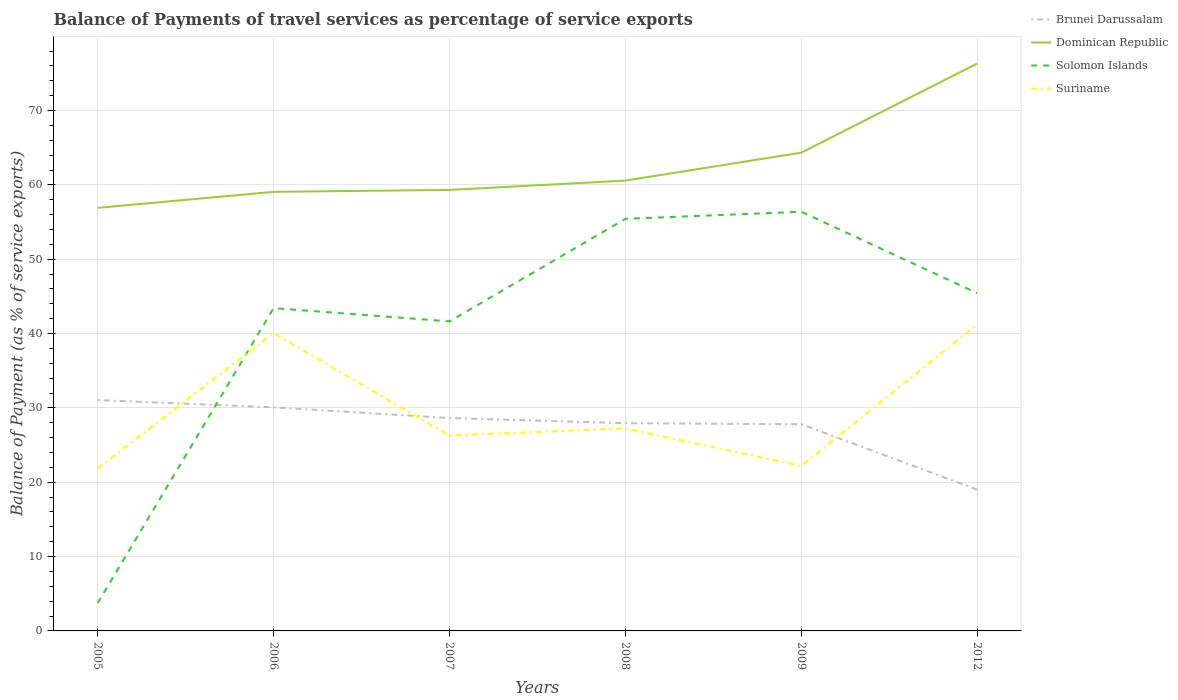How many different coloured lines are there?
Offer a terse response. 4. Is the number of lines equal to the number of legend labels?
Keep it short and to the point. Yes. Across all years, what is the maximum balance of payments of travel services in Suriname?
Offer a very short reply. 21.85. What is the total balance of payments of travel services in Dominican Republic in the graph?
Give a very brief answer. -1.51. What is the difference between the highest and the second highest balance of payments of travel services in Suriname?
Provide a short and direct response. 19.35. Is the balance of payments of travel services in Solomon Islands strictly greater than the balance of payments of travel services in Brunei Darussalam over the years?
Offer a terse response. No. How many lines are there?
Your response must be concise. 4. How many years are there in the graph?
Give a very brief answer. 6. What is the difference between two consecutive major ticks on the Y-axis?
Provide a succinct answer. 10. How many legend labels are there?
Provide a short and direct response. 4. What is the title of the graph?
Your answer should be compact. Balance of Payments of travel services as percentage of service exports. Does "United Arab Emirates" appear as one of the legend labels in the graph?
Offer a terse response. No. What is the label or title of the Y-axis?
Your answer should be very brief. Balance of Payment (as % of service exports). What is the Balance of Payment (as % of service exports) of Brunei Darussalam in 2005?
Offer a very short reply. 31.06. What is the Balance of Payment (as % of service exports) of Dominican Republic in 2005?
Provide a succinct answer. 56.92. What is the Balance of Payment (as % of service exports) of Solomon Islands in 2005?
Provide a succinct answer. 3.74. What is the Balance of Payment (as % of service exports) in Suriname in 2005?
Give a very brief answer. 21.85. What is the Balance of Payment (as % of service exports) in Brunei Darussalam in 2006?
Offer a very short reply. 30.08. What is the Balance of Payment (as % of service exports) of Dominican Republic in 2006?
Offer a terse response. 59.07. What is the Balance of Payment (as % of service exports) of Solomon Islands in 2006?
Make the answer very short. 43.42. What is the Balance of Payment (as % of service exports) in Suriname in 2006?
Your answer should be compact. 40.07. What is the Balance of Payment (as % of service exports) in Brunei Darussalam in 2007?
Offer a very short reply. 28.64. What is the Balance of Payment (as % of service exports) in Dominican Republic in 2007?
Offer a very short reply. 59.33. What is the Balance of Payment (as % of service exports) in Solomon Islands in 2007?
Provide a succinct answer. 41.65. What is the Balance of Payment (as % of service exports) of Suriname in 2007?
Offer a terse response. 26.28. What is the Balance of Payment (as % of service exports) of Brunei Darussalam in 2008?
Make the answer very short. 27.95. What is the Balance of Payment (as % of service exports) of Dominican Republic in 2008?
Keep it short and to the point. 60.58. What is the Balance of Payment (as % of service exports) in Solomon Islands in 2008?
Offer a terse response. 55.44. What is the Balance of Payment (as % of service exports) in Suriname in 2008?
Your response must be concise. 27.23. What is the Balance of Payment (as % of service exports) in Brunei Darussalam in 2009?
Offer a very short reply. 27.8. What is the Balance of Payment (as % of service exports) in Dominican Republic in 2009?
Provide a succinct answer. 64.34. What is the Balance of Payment (as % of service exports) of Solomon Islands in 2009?
Your answer should be compact. 56.39. What is the Balance of Payment (as % of service exports) of Suriname in 2009?
Give a very brief answer. 22.18. What is the Balance of Payment (as % of service exports) in Brunei Darussalam in 2012?
Your answer should be compact. 19.01. What is the Balance of Payment (as % of service exports) of Dominican Republic in 2012?
Keep it short and to the point. 76.33. What is the Balance of Payment (as % of service exports) in Solomon Islands in 2012?
Make the answer very short. 45.44. What is the Balance of Payment (as % of service exports) in Suriname in 2012?
Provide a short and direct response. 41.21. Across all years, what is the maximum Balance of Payment (as % of service exports) in Brunei Darussalam?
Make the answer very short. 31.06. Across all years, what is the maximum Balance of Payment (as % of service exports) of Dominican Republic?
Provide a short and direct response. 76.33. Across all years, what is the maximum Balance of Payment (as % of service exports) in Solomon Islands?
Provide a succinct answer. 56.39. Across all years, what is the maximum Balance of Payment (as % of service exports) in Suriname?
Make the answer very short. 41.21. Across all years, what is the minimum Balance of Payment (as % of service exports) of Brunei Darussalam?
Make the answer very short. 19.01. Across all years, what is the minimum Balance of Payment (as % of service exports) in Dominican Republic?
Your answer should be very brief. 56.92. Across all years, what is the minimum Balance of Payment (as % of service exports) in Solomon Islands?
Offer a terse response. 3.74. Across all years, what is the minimum Balance of Payment (as % of service exports) in Suriname?
Ensure brevity in your answer.  21.85. What is the total Balance of Payment (as % of service exports) in Brunei Darussalam in the graph?
Your answer should be compact. 164.53. What is the total Balance of Payment (as % of service exports) of Dominican Republic in the graph?
Offer a very short reply. 376.57. What is the total Balance of Payment (as % of service exports) in Solomon Islands in the graph?
Your answer should be very brief. 246.08. What is the total Balance of Payment (as % of service exports) in Suriname in the graph?
Your response must be concise. 178.82. What is the difference between the Balance of Payment (as % of service exports) in Brunei Darussalam in 2005 and that in 2006?
Offer a terse response. 0.98. What is the difference between the Balance of Payment (as % of service exports) in Dominican Republic in 2005 and that in 2006?
Your answer should be compact. -2.15. What is the difference between the Balance of Payment (as % of service exports) in Solomon Islands in 2005 and that in 2006?
Provide a short and direct response. -39.69. What is the difference between the Balance of Payment (as % of service exports) in Suriname in 2005 and that in 2006?
Your response must be concise. -18.22. What is the difference between the Balance of Payment (as % of service exports) of Brunei Darussalam in 2005 and that in 2007?
Make the answer very short. 2.42. What is the difference between the Balance of Payment (as % of service exports) of Dominican Republic in 2005 and that in 2007?
Give a very brief answer. -2.41. What is the difference between the Balance of Payment (as % of service exports) in Solomon Islands in 2005 and that in 2007?
Your answer should be compact. -37.91. What is the difference between the Balance of Payment (as % of service exports) of Suriname in 2005 and that in 2007?
Keep it short and to the point. -4.43. What is the difference between the Balance of Payment (as % of service exports) in Brunei Darussalam in 2005 and that in 2008?
Make the answer very short. 3.11. What is the difference between the Balance of Payment (as % of service exports) of Dominican Republic in 2005 and that in 2008?
Offer a terse response. -3.67. What is the difference between the Balance of Payment (as % of service exports) in Solomon Islands in 2005 and that in 2008?
Provide a succinct answer. -51.7. What is the difference between the Balance of Payment (as % of service exports) in Suriname in 2005 and that in 2008?
Ensure brevity in your answer.  -5.38. What is the difference between the Balance of Payment (as % of service exports) in Brunei Darussalam in 2005 and that in 2009?
Provide a short and direct response. 3.25. What is the difference between the Balance of Payment (as % of service exports) of Dominican Republic in 2005 and that in 2009?
Your answer should be compact. -7.42. What is the difference between the Balance of Payment (as % of service exports) in Solomon Islands in 2005 and that in 2009?
Ensure brevity in your answer.  -52.65. What is the difference between the Balance of Payment (as % of service exports) of Suriname in 2005 and that in 2009?
Offer a very short reply. -0.33. What is the difference between the Balance of Payment (as % of service exports) of Brunei Darussalam in 2005 and that in 2012?
Give a very brief answer. 12.05. What is the difference between the Balance of Payment (as % of service exports) in Dominican Republic in 2005 and that in 2012?
Provide a succinct answer. -19.41. What is the difference between the Balance of Payment (as % of service exports) of Solomon Islands in 2005 and that in 2012?
Offer a very short reply. -41.7. What is the difference between the Balance of Payment (as % of service exports) in Suriname in 2005 and that in 2012?
Give a very brief answer. -19.35. What is the difference between the Balance of Payment (as % of service exports) of Brunei Darussalam in 2006 and that in 2007?
Your answer should be compact. 1.44. What is the difference between the Balance of Payment (as % of service exports) in Dominican Republic in 2006 and that in 2007?
Offer a very short reply. -0.26. What is the difference between the Balance of Payment (as % of service exports) in Solomon Islands in 2006 and that in 2007?
Your answer should be compact. 1.78. What is the difference between the Balance of Payment (as % of service exports) of Suriname in 2006 and that in 2007?
Your answer should be very brief. 13.79. What is the difference between the Balance of Payment (as % of service exports) of Brunei Darussalam in 2006 and that in 2008?
Give a very brief answer. 2.13. What is the difference between the Balance of Payment (as % of service exports) of Dominican Republic in 2006 and that in 2008?
Keep it short and to the point. -1.51. What is the difference between the Balance of Payment (as % of service exports) in Solomon Islands in 2006 and that in 2008?
Your response must be concise. -12.01. What is the difference between the Balance of Payment (as % of service exports) in Suriname in 2006 and that in 2008?
Provide a short and direct response. 12.83. What is the difference between the Balance of Payment (as % of service exports) of Brunei Darussalam in 2006 and that in 2009?
Ensure brevity in your answer.  2.28. What is the difference between the Balance of Payment (as % of service exports) of Dominican Republic in 2006 and that in 2009?
Provide a succinct answer. -5.27. What is the difference between the Balance of Payment (as % of service exports) of Solomon Islands in 2006 and that in 2009?
Your answer should be very brief. -12.96. What is the difference between the Balance of Payment (as % of service exports) of Suriname in 2006 and that in 2009?
Give a very brief answer. 17.88. What is the difference between the Balance of Payment (as % of service exports) in Brunei Darussalam in 2006 and that in 2012?
Offer a terse response. 11.07. What is the difference between the Balance of Payment (as % of service exports) in Dominican Republic in 2006 and that in 2012?
Offer a terse response. -17.26. What is the difference between the Balance of Payment (as % of service exports) of Solomon Islands in 2006 and that in 2012?
Your answer should be compact. -2.02. What is the difference between the Balance of Payment (as % of service exports) of Suriname in 2006 and that in 2012?
Offer a very short reply. -1.14. What is the difference between the Balance of Payment (as % of service exports) of Brunei Darussalam in 2007 and that in 2008?
Your answer should be very brief. 0.69. What is the difference between the Balance of Payment (as % of service exports) in Dominican Republic in 2007 and that in 2008?
Ensure brevity in your answer.  -1.25. What is the difference between the Balance of Payment (as % of service exports) of Solomon Islands in 2007 and that in 2008?
Make the answer very short. -13.79. What is the difference between the Balance of Payment (as % of service exports) of Suriname in 2007 and that in 2008?
Give a very brief answer. -0.95. What is the difference between the Balance of Payment (as % of service exports) in Brunei Darussalam in 2007 and that in 2009?
Your answer should be very brief. 0.84. What is the difference between the Balance of Payment (as % of service exports) in Dominican Republic in 2007 and that in 2009?
Make the answer very short. -5.01. What is the difference between the Balance of Payment (as % of service exports) of Solomon Islands in 2007 and that in 2009?
Make the answer very short. -14.74. What is the difference between the Balance of Payment (as % of service exports) in Suriname in 2007 and that in 2009?
Your response must be concise. 4.1. What is the difference between the Balance of Payment (as % of service exports) of Brunei Darussalam in 2007 and that in 2012?
Provide a succinct answer. 9.63. What is the difference between the Balance of Payment (as % of service exports) of Dominican Republic in 2007 and that in 2012?
Keep it short and to the point. -17. What is the difference between the Balance of Payment (as % of service exports) in Solomon Islands in 2007 and that in 2012?
Make the answer very short. -3.8. What is the difference between the Balance of Payment (as % of service exports) of Suriname in 2007 and that in 2012?
Your answer should be very brief. -14.92. What is the difference between the Balance of Payment (as % of service exports) of Brunei Darussalam in 2008 and that in 2009?
Make the answer very short. 0.14. What is the difference between the Balance of Payment (as % of service exports) of Dominican Republic in 2008 and that in 2009?
Your answer should be compact. -3.76. What is the difference between the Balance of Payment (as % of service exports) in Solomon Islands in 2008 and that in 2009?
Ensure brevity in your answer.  -0.95. What is the difference between the Balance of Payment (as % of service exports) in Suriname in 2008 and that in 2009?
Give a very brief answer. 5.05. What is the difference between the Balance of Payment (as % of service exports) in Brunei Darussalam in 2008 and that in 2012?
Keep it short and to the point. 8.94. What is the difference between the Balance of Payment (as % of service exports) in Dominican Republic in 2008 and that in 2012?
Your answer should be compact. -15.75. What is the difference between the Balance of Payment (as % of service exports) of Solomon Islands in 2008 and that in 2012?
Your answer should be compact. 9.99. What is the difference between the Balance of Payment (as % of service exports) of Suriname in 2008 and that in 2012?
Give a very brief answer. -13.97. What is the difference between the Balance of Payment (as % of service exports) of Brunei Darussalam in 2009 and that in 2012?
Ensure brevity in your answer.  8.8. What is the difference between the Balance of Payment (as % of service exports) of Dominican Republic in 2009 and that in 2012?
Keep it short and to the point. -11.99. What is the difference between the Balance of Payment (as % of service exports) of Solomon Islands in 2009 and that in 2012?
Keep it short and to the point. 10.95. What is the difference between the Balance of Payment (as % of service exports) of Suriname in 2009 and that in 2012?
Offer a very short reply. -19.02. What is the difference between the Balance of Payment (as % of service exports) of Brunei Darussalam in 2005 and the Balance of Payment (as % of service exports) of Dominican Republic in 2006?
Your answer should be very brief. -28.01. What is the difference between the Balance of Payment (as % of service exports) of Brunei Darussalam in 2005 and the Balance of Payment (as % of service exports) of Solomon Islands in 2006?
Ensure brevity in your answer.  -12.37. What is the difference between the Balance of Payment (as % of service exports) of Brunei Darussalam in 2005 and the Balance of Payment (as % of service exports) of Suriname in 2006?
Your answer should be very brief. -9.01. What is the difference between the Balance of Payment (as % of service exports) in Dominican Republic in 2005 and the Balance of Payment (as % of service exports) in Solomon Islands in 2006?
Give a very brief answer. 13.49. What is the difference between the Balance of Payment (as % of service exports) of Dominican Republic in 2005 and the Balance of Payment (as % of service exports) of Suriname in 2006?
Provide a short and direct response. 16.85. What is the difference between the Balance of Payment (as % of service exports) in Solomon Islands in 2005 and the Balance of Payment (as % of service exports) in Suriname in 2006?
Provide a succinct answer. -36.33. What is the difference between the Balance of Payment (as % of service exports) of Brunei Darussalam in 2005 and the Balance of Payment (as % of service exports) of Dominican Republic in 2007?
Your response must be concise. -28.27. What is the difference between the Balance of Payment (as % of service exports) in Brunei Darussalam in 2005 and the Balance of Payment (as % of service exports) in Solomon Islands in 2007?
Offer a very short reply. -10.59. What is the difference between the Balance of Payment (as % of service exports) in Brunei Darussalam in 2005 and the Balance of Payment (as % of service exports) in Suriname in 2007?
Your answer should be very brief. 4.77. What is the difference between the Balance of Payment (as % of service exports) in Dominican Republic in 2005 and the Balance of Payment (as % of service exports) in Solomon Islands in 2007?
Provide a short and direct response. 15.27. What is the difference between the Balance of Payment (as % of service exports) in Dominican Republic in 2005 and the Balance of Payment (as % of service exports) in Suriname in 2007?
Provide a succinct answer. 30.63. What is the difference between the Balance of Payment (as % of service exports) of Solomon Islands in 2005 and the Balance of Payment (as % of service exports) of Suriname in 2007?
Offer a terse response. -22.54. What is the difference between the Balance of Payment (as % of service exports) in Brunei Darussalam in 2005 and the Balance of Payment (as % of service exports) in Dominican Republic in 2008?
Your response must be concise. -29.53. What is the difference between the Balance of Payment (as % of service exports) of Brunei Darussalam in 2005 and the Balance of Payment (as % of service exports) of Solomon Islands in 2008?
Your answer should be very brief. -24.38. What is the difference between the Balance of Payment (as % of service exports) in Brunei Darussalam in 2005 and the Balance of Payment (as % of service exports) in Suriname in 2008?
Provide a succinct answer. 3.82. What is the difference between the Balance of Payment (as % of service exports) of Dominican Republic in 2005 and the Balance of Payment (as % of service exports) of Solomon Islands in 2008?
Offer a very short reply. 1.48. What is the difference between the Balance of Payment (as % of service exports) of Dominican Republic in 2005 and the Balance of Payment (as % of service exports) of Suriname in 2008?
Offer a very short reply. 29.68. What is the difference between the Balance of Payment (as % of service exports) of Solomon Islands in 2005 and the Balance of Payment (as % of service exports) of Suriname in 2008?
Offer a terse response. -23.5. What is the difference between the Balance of Payment (as % of service exports) of Brunei Darussalam in 2005 and the Balance of Payment (as % of service exports) of Dominican Republic in 2009?
Keep it short and to the point. -33.28. What is the difference between the Balance of Payment (as % of service exports) in Brunei Darussalam in 2005 and the Balance of Payment (as % of service exports) in Solomon Islands in 2009?
Offer a very short reply. -25.33. What is the difference between the Balance of Payment (as % of service exports) in Brunei Darussalam in 2005 and the Balance of Payment (as % of service exports) in Suriname in 2009?
Your answer should be compact. 8.87. What is the difference between the Balance of Payment (as % of service exports) of Dominican Republic in 2005 and the Balance of Payment (as % of service exports) of Solomon Islands in 2009?
Offer a terse response. 0.53. What is the difference between the Balance of Payment (as % of service exports) of Dominican Republic in 2005 and the Balance of Payment (as % of service exports) of Suriname in 2009?
Keep it short and to the point. 34.73. What is the difference between the Balance of Payment (as % of service exports) in Solomon Islands in 2005 and the Balance of Payment (as % of service exports) in Suriname in 2009?
Your answer should be compact. -18.45. What is the difference between the Balance of Payment (as % of service exports) in Brunei Darussalam in 2005 and the Balance of Payment (as % of service exports) in Dominican Republic in 2012?
Make the answer very short. -45.27. What is the difference between the Balance of Payment (as % of service exports) of Brunei Darussalam in 2005 and the Balance of Payment (as % of service exports) of Solomon Islands in 2012?
Offer a terse response. -14.39. What is the difference between the Balance of Payment (as % of service exports) in Brunei Darussalam in 2005 and the Balance of Payment (as % of service exports) in Suriname in 2012?
Make the answer very short. -10.15. What is the difference between the Balance of Payment (as % of service exports) of Dominican Republic in 2005 and the Balance of Payment (as % of service exports) of Solomon Islands in 2012?
Make the answer very short. 11.47. What is the difference between the Balance of Payment (as % of service exports) of Dominican Republic in 2005 and the Balance of Payment (as % of service exports) of Suriname in 2012?
Your answer should be very brief. 15.71. What is the difference between the Balance of Payment (as % of service exports) in Solomon Islands in 2005 and the Balance of Payment (as % of service exports) in Suriname in 2012?
Keep it short and to the point. -37.47. What is the difference between the Balance of Payment (as % of service exports) of Brunei Darussalam in 2006 and the Balance of Payment (as % of service exports) of Dominican Republic in 2007?
Make the answer very short. -29.25. What is the difference between the Balance of Payment (as % of service exports) in Brunei Darussalam in 2006 and the Balance of Payment (as % of service exports) in Solomon Islands in 2007?
Offer a terse response. -11.57. What is the difference between the Balance of Payment (as % of service exports) of Brunei Darussalam in 2006 and the Balance of Payment (as % of service exports) of Suriname in 2007?
Give a very brief answer. 3.8. What is the difference between the Balance of Payment (as % of service exports) in Dominican Republic in 2006 and the Balance of Payment (as % of service exports) in Solomon Islands in 2007?
Make the answer very short. 17.42. What is the difference between the Balance of Payment (as % of service exports) in Dominican Republic in 2006 and the Balance of Payment (as % of service exports) in Suriname in 2007?
Offer a very short reply. 32.79. What is the difference between the Balance of Payment (as % of service exports) of Solomon Islands in 2006 and the Balance of Payment (as % of service exports) of Suriname in 2007?
Ensure brevity in your answer.  17.14. What is the difference between the Balance of Payment (as % of service exports) in Brunei Darussalam in 2006 and the Balance of Payment (as % of service exports) in Dominican Republic in 2008?
Offer a terse response. -30.5. What is the difference between the Balance of Payment (as % of service exports) in Brunei Darussalam in 2006 and the Balance of Payment (as % of service exports) in Solomon Islands in 2008?
Your answer should be compact. -25.36. What is the difference between the Balance of Payment (as % of service exports) in Brunei Darussalam in 2006 and the Balance of Payment (as % of service exports) in Suriname in 2008?
Your response must be concise. 2.85. What is the difference between the Balance of Payment (as % of service exports) of Dominican Republic in 2006 and the Balance of Payment (as % of service exports) of Solomon Islands in 2008?
Make the answer very short. 3.63. What is the difference between the Balance of Payment (as % of service exports) in Dominican Republic in 2006 and the Balance of Payment (as % of service exports) in Suriname in 2008?
Your response must be concise. 31.83. What is the difference between the Balance of Payment (as % of service exports) in Solomon Islands in 2006 and the Balance of Payment (as % of service exports) in Suriname in 2008?
Offer a terse response. 16.19. What is the difference between the Balance of Payment (as % of service exports) of Brunei Darussalam in 2006 and the Balance of Payment (as % of service exports) of Dominican Republic in 2009?
Keep it short and to the point. -34.26. What is the difference between the Balance of Payment (as % of service exports) of Brunei Darussalam in 2006 and the Balance of Payment (as % of service exports) of Solomon Islands in 2009?
Your answer should be compact. -26.31. What is the difference between the Balance of Payment (as % of service exports) of Brunei Darussalam in 2006 and the Balance of Payment (as % of service exports) of Suriname in 2009?
Make the answer very short. 7.9. What is the difference between the Balance of Payment (as % of service exports) in Dominican Republic in 2006 and the Balance of Payment (as % of service exports) in Solomon Islands in 2009?
Give a very brief answer. 2.68. What is the difference between the Balance of Payment (as % of service exports) of Dominican Republic in 2006 and the Balance of Payment (as % of service exports) of Suriname in 2009?
Offer a very short reply. 36.89. What is the difference between the Balance of Payment (as % of service exports) of Solomon Islands in 2006 and the Balance of Payment (as % of service exports) of Suriname in 2009?
Make the answer very short. 21.24. What is the difference between the Balance of Payment (as % of service exports) in Brunei Darussalam in 2006 and the Balance of Payment (as % of service exports) in Dominican Republic in 2012?
Your response must be concise. -46.25. What is the difference between the Balance of Payment (as % of service exports) in Brunei Darussalam in 2006 and the Balance of Payment (as % of service exports) in Solomon Islands in 2012?
Offer a very short reply. -15.36. What is the difference between the Balance of Payment (as % of service exports) in Brunei Darussalam in 2006 and the Balance of Payment (as % of service exports) in Suriname in 2012?
Offer a terse response. -11.12. What is the difference between the Balance of Payment (as % of service exports) in Dominican Republic in 2006 and the Balance of Payment (as % of service exports) in Solomon Islands in 2012?
Provide a short and direct response. 13.63. What is the difference between the Balance of Payment (as % of service exports) of Dominican Republic in 2006 and the Balance of Payment (as % of service exports) of Suriname in 2012?
Keep it short and to the point. 17.86. What is the difference between the Balance of Payment (as % of service exports) in Solomon Islands in 2006 and the Balance of Payment (as % of service exports) in Suriname in 2012?
Your response must be concise. 2.22. What is the difference between the Balance of Payment (as % of service exports) of Brunei Darussalam in 2007 and the Balance of Payment (as % of service exports) of Dominican Republic in 2008?
Offer a terse response. -31.94. What is the difference between the Balance of Payment (as % of service exports) in Brunei Darussalam in 2007 and the Balance of Payment (as % of service exports) in Solomon Islands in 2008?
Make the answer very short. -26.8. What is the difference between the Balance of Payment (as % of service exports) in Brunei Darussalam in 2007 and the Balance of Payment (as % of service exports) in Suriname in 2008?
Ensure brevity in your answer.  1.41. What is the difference between the Balance of Payment (as % of service exports) of Dominican Republic in 2007 and the Balance of Payment (as % of service exports) of Solomon Islands in 2008?
Ensure brevity in your answer.  3.89. What is the difference between the Balance of Payment (as % of service exports) of Dominican Republic in 2007 and the Balance of Payment (as % of service exports) of Suriname in 2008?
Make the answer very short. 32.09. What is the difference between the Balance of Payment (as % of service exports) of Solomon Islands in 2007 and the Balance of Payment (as % of service exports) of Suriname in 2008?
Keep it short and to the point. 14.41. What is the difference between the Balance of Payment (as % of service exports) of Brunei Darussalam in 2007 and the Balance of Payment (as % of service exports) of Dominican Republic in 2009?
Ensure brevity in your answer.  -35.7. What is the difference between the Balance of Payment (as % of service exports) in Brunei Darussalam in 2007 and the Balance of Payment (as % of service exports) in Solomon Islands in 2009?
Offer a terse response. -27.75. What is the difference between the Balance of Payment (as % of service exports) in Brunei Darussalam in 2007 and the Balance of Payment (as % of service exports) in Suriname in 2009?
Provide a short and direct response. 6.46. What is the difference between the Balance of Payment (as % of service exports) of Dominican Republic in 2007 and the Balance of Payment (as % of service exports) of Solomon Islands in 2009?
Offer a terse response. 2.94. What is the difference between the Balance of Payment (as % of service exports) in Dominican Republic in 2007 and the Balance of Payment (as % of service exports) in Suriname in 2009?
Offer a terse response. 37.15. What is the difference between the Balance of Payment (as % of service exports) in Solomon Islands in 2007 and the Balance of Payment (as % of service exports) in Suriname in 2009?
Keep it short and to the point. 19.46. What is the difference between the Balance of Payment (as % of service exports) of Brunei Darussalam in 2007 and the Balance of Payment (as % of service exports) of Dominican Republic in 2012?
Your answer should be compact. -47.69. What is the difference between the Balance of Payment (as % of service exports) in Brunei Darussalam in 2007 and the Balance of Payment (as % of service exports) in Solomon Islands in 2012?
Give a very brief answer. -16.8. What is the difference between the Balance of Payment (as % of service exports) in Brunei Darussalam in 2007 and the Balance of Payment (as % of service exports) in Suriname in 2012?
Make the answer very short. -12.56. What is the difference between the Balance of Payment (as % of service exports) in Dominican Republic in 2007 and the Balance of Payment (as % of service exports) in Solomon Islands in 2012?
Give a very brief answer. 13.89. What is the difference between the Balance of Payment (as % of service exports) in Dominican Republic in 2007 and the Balance of Payment (as % of service exports) in Suriname in 2012?
Give a very brief answer. 18.12. What is the difference between the Balance of Payment (as % of service exports) of Solomon Islands in 2007 and the Balance of Payment (as % of service exports) of Suriname in 2012?
Give a very brief answer. 0.44. What is the difference between the Balance of Payment (as % of service exports) in Brunei Darussalam in 2008 and the Balance of Payment (as % of service exports) in Dominican Republic in 2009?
Offer a very short reply. -36.39. What is the difference between the Balance of Payment (as % of service exports) of Brunei Darussalam in 2008 and the Balance of Payment (as % of service exports) of Solomon Islands in 2009?
Your answer should be very brief. -28.44. What is the difference between the Balance of Payment (as % of service exports) in Brunei Darussalam in 2008 and the Balance of Payment (as % of service exports) in Suriname in 2009?
Offer a terse response. 5.76. What is the difference between the Balance of Payment (as % of service exports) in Dominican Republic in 2008 and the Balance of Payment (as % of service exports) in Solomon Islands in 2009?
Provide a succinct answer. 4.19. What is the difference between the Balance of Payment (as % of service exports) in Dominican Republic in 2008 and the Balance of Payment (as % of service exports) in Suriname in 2009?
Your answer should be very brief. 38.4. What is the difference between the Balance of Payment (as % of service exports) in Solomon Islands in 2008 and the Balance of Payment (as % of service exports) in Suriname in 2009?
Make the answer very short. 33.25. What is the difference between the Balance of Payment (as % of service exports) in Brunei Darussalam in 2008 and the Balance of Payment (as % of service exports) in Dominican Republic in 2012?
Keep it short and to the point. -48.38. What is the difference between the Balance of Payment (as % of service exports) of Brunei Darussalam in 2008 and the Balance of Payment (as % of service exports) of Solomon Islands in 2012?
Your answer should be very brief. -17.5. What is the difference between the Balance of Payment (as % of service exports) of Brunei Darussalam in 2008 and the Balance of Payment (as % of service exports) of Suriname in 2012?
Your answer should be compact. -13.26. What is the difference between the Balance of Payment (as % of service exports) of Dominican Republic in 2008 and the Balance of Payment (as % of service exports) of Solomon Islands in 2012?
Offer a terse response. 15.14. What is the difference between the Balance of Payment (as % of service exports) of Dominican Republic in 2008 and the Balance of Payment (as % of service exports) of Suriname in 2012?
Ensure brevity in your answer.  19.38. What is the difference between the Balance of Payment (as % of service exports) in Solomon Islands in 2008 and the Balance of Payment (as % of service exports) in Suriname in 2012?
Ensure brevity in your answer.  14.23. What is the difference between the Balance of Payment (as % of service exports) of Brunei Darussalam in 2009 and the Balance of Payment (as % of service exports) of Dominican Republic in 2012?
Ensure brevity in your answer.  -48.53. What is the difference between the Balance of Payment (as % of service exports) of Brunei Darussalam in 2009 and the Balance of Payment (as % of service exports) of Solomon Islands in 2012?
Offer a very short reply. -17.64. What is the difference between the Balance of Payment (as % of service exports) of Brunei Darussalam in 2009 and the Balance of Payment (as % of service exports) of Suriname in 2012?
Your response must be concise. -13.4. What is the difference between the Balance of Payment (as % of service exports) of Dominican Republic in 2009 and the Balance of Payment (as % of service exports) of Solomon Islands in 2012?
Make the answer very short. 18.9. What is the difference between the Balance of Payment (as % of service exports) in Dominican Republic in 2009 and the Balance of Payment (as % of service exports) in Suriname in 2012?
Make the answer very short. 23.14. What is the difference between the Balance of Payment (as % of service exports) of Solomon Islands in 2009 and the Balance of Payment (as % of service exports) of Suriname in 2012?
Offer a terse response. 15.18. What is the average Balance of Payment (as % of service exports) in Brunei Darussalam per year?
Ensure brevity in your answer.  27.42. What is the average Balance of Payment (as % of service exports) of Dominican Republic per year?
Offer a very short reply. 62.76. What is the average Balance of Payment (as % of service exports) of Solomon Islands per year?
Make the answer very short. 41.01. What is the average Balance of Payment (as % of service exports) of Suriname per year?
Make the answer very short. 29.8. In the year 2005, what is the difference between the Balance of Payment (as % of service exports) in Brunei Darussalam and Balance of Payment (as % of service exports) in Dominican Republic?
Your answer should be very brief. -25.86. In the year 2005, what is the difference between the Balance of Payment (as % of service exports) in Brunei Darussalam and Balance of Payment (as % of service exports) in Solomon Islands?
Make the answer very short. 27.32. In the year 2005, what is the difference between the Balance of Payment (as % of service exports) in Brunei Darussalam and Balance of Payment (as % of service exports) in Suriname?
Provide a succinct answer. 9.2. In the year 2005, what is the difference between the Balance of Payment (as % of service exports) of Dominican Republic and Balance of Payment (as % of service exports) of Solomon Islands?
Give a very brief answer. 53.18. In the year 2005, what is the difference between the Balance of Payment (as % of service exports) in Dominican Republic and Balance of Payment (as % of service exports) in Suriname?
Ensure brevity in your answer.  35.06. In the year 2005, what is the difference between the Balance of Payment (as % of service exports) in Solomon Islands and Balance of Payment (as % of service exports) in Suriname?
Give a very brief answer. -18.11. In the year 2006, what is the difference between the Balance of Payment (as % of service exports) in Brunei Darussalam and Balance of Payment (as % of service exports) in Dominican Republic?
Keep it short and to the point. -28.99. In the year 2006, what is the difference between the Balance of Payment (as % of service exports) of Brunei Darussalam and Balance of Payment (as % of service exports) of Solomon Islands?
Provide a short and direct response. -13.34. In the year 2006, what is the difference between the Balance of Payment (as % of service exports) in Brunei Darussalam and Balance of Payment (as % of service exports) in Suriname?
Provide a short and direct response. -9.99. In the year 2006, what is the difference between the Balance of Payment (as % of service exports) in Dominican Republic and Balance of Payment (as % of service exports) in Solomon Islands?
Offer a very short reply. 15.64. In the year 2006, what is the difference between the Balance of Payment (as % of service exports) in Dominican Republic and Balance of Payment (as % of service exports) in Suriname?
Your response must be concise. 19. In the year 2006, what is the difference between the Balance of Payment (as % of service exports) of Solomon Islands and Balance of Payment (as % of service exports) of Suriname?
Offer a very short reply. 3.36. In the year 2007, what is the difference between the Balance of Payment (as % of service exports) in Brunei Darussalam and Balance of Payment (as % of service exports) in Dominican Republic?
Your response must be concise. -30.69. In the year 2007, what is the difference between the Balance of Payment (as % of service exports) of Brunei Darussalam and Balance of Payment (as % of service exports) of Solomon Islands?
Your answer should be very brief. -13.01. In the year 2007, what is the difference between the Balance of Payment (as % of service exports) in Brunei Darussalam and Balance of Payment (as % of service exports) in Suriname?
Provide a short and direct response. 2.36. In the year 2007, what is the difference between the Balance of Payment (as % of service exports) in Dominican Republic and Balance of Payment (as % of service exports) in Solomon Islands?
Give a very brief answer. 17.68. In the year 2007, what is the difference between the Balance of Payment (as % of service exports) in Dominican Republic and Balance of Payment (as % of service exports) in Suriname?
Offer a very short reply. 33.05. In the year 2007, what is the difference between the Balance of Payment (as % of service exports) of Solomon Islands and Balance of Payment (as % of service exports) of Suriname?
Provide a short and direct response. 15.36. In the year 2008, what is the difference between the Balance of Payment (as % of service exports) of Brunei Darussalam and Balance of Payment (as % of service exports) of Dominican Republic?
Keep it short and to the point. -32.64. In the year 2008, what is the difference between the Balance of Payment (as % of service exports) in Brunei Darussalam and Balance of Payment (as % of service exports) in Solomon Islands?
Ensure brevity in your answer.  -27.49. In the year 2008, what is the difference between the Balance of Payment (as % of service exports) of Brunei Darussalam and Balance of Payment (as % of service exports) of Suriname?
Provide a short and direct response. 0.71. In the year 2008, what is the difference between the Balance of Payment (as % of service exports) of Dominican Republic and Balance of Payment (as % of service exports) of Solomon Islands?
Your response must be concise. 5.15. In the year 2008, what is the difference between the Balance of Payment (as % of service exports) in Dominican Republic and Balance of Payment (as % of service exports) in Suriname?
Give a very brief answer. 33.35. In the year 2008, what is the difference between the Balance of Payment (as % of service exports) of Solomon Islands and Balance of Payment (as % of service exports) of Suriname?
Provide a succinct answer. 28.2. In the year 2009, what is the difference between the Balance of Payment (as % of service exports) in Brunei Darussalam and Balance of Payment (as % of service exports) in Dominican Republic?
Provide a succinct answer. -36.54. In the year 2009, what is the difference between the Balance of Payment (as % of service exports) of Brunei Darussalam and Balance of Payment (as % of service exports) of Solomon Islands?
Make the answer very short. -28.59. In the year 2009, what is the difference between the Balance of Payment (as % of service exports) in Brunei Darussalam and Balance of Payment (as % of service exports) in Suriname?
Give a very brief answer. 5.62. In the year 2009, what is the difference between the Balance of Payment (as % of service exports) of Dominican Republic and Balance of Payment (as % of service exports) of Solomon Islands?
Your answer should be very brief. 7.95. In the year 2009, what is the difference between the Balance of Payment (as % of service exports) of Dominican Republic and Balance of Payment (as % of service exports) of Suriname?
Provide a short and direct response. 42.16. In the year 2009, what is the difference between the Balance of Payment (as % of service exports) of Solomon Islands and Balance of Payment (as % of service exports) of Suriname?
Provide a succinct answer. 34.21. In the year 2012, what is the difference between the Balance of Payment (as % of service exports) in Brunei Darussalam and Balance of Payment (as % of service exports) in Dominican Republic?
Keep it short and to the point. -57.32. In the year 2012, what is the difference between the Balance of Payment (as % of service exports) in Brunei Darussalam and Balance of Payment (as % of service exports) in Solomon Islands?
Keep it short and to the point. -26.43. In the year 2012, what is the difference between the Balance of Payment (as % of service exports) in Brunei Darussalam and Balance of Payment (as % of service exports) in Suriname?
Offer a terse response. -22.2. In the year 2012, what is the difference between the Balance of Payment (as % of service exports) in Dominican Republic and Balance of Payment (as % of service exports) in Solomon Islands?
Keep it short and to the point. 30.89. In the year 2012, what is the difference between the Balance of Payment (as % of service exports) of Dominican Republic and Balance of Payment (as % of service exports) of Suriname?
Give a very brief answer. 35.12. In the year 2012, what is the difference between the Balance of Payment (as % of service exports) of Solomon Islands and Balance of Payment (as % of service exports) of Suriname?
Your response must be concise. 4.24. What is the ratio of the Balance of Payment (as % of service exports) of Brunei Darussalam in 2005 to that in 2006?
Provide a short and direct response. 1.03. What is the ratio of the Balance of Payment (as % of service exports) of Dominican Republic in 2005 to that in 2006?
Ensure brevity in your answer.  0.96. What is the ratio of the Balance of Payment (as % of service exports) in Solomon Islands in 2005 to that in 2006?
Your response must be concise. 0.09. What is the ratio of the Balance of Payment (as % of service exports) in Suriname in 2005 to that in 2006?
Offer a very short reply. 0.55. What is the ratio of the Balance of Payment (as % of service exports) of Brunei Darussalam in 2005 to that in 2007?
Keep it short and to the point. 1.08. What is the ratio of the Balance of Payment (as % of service exports) in Dominican Republic in 2005 to that in 2007?
Keep it short and to the point. 0.96. What is the ratio of the Balance of Payment (as % of service exports) in Solomon Islands in 2005 to that in 2007?
Make the answer very short. 0.09. What is the ratio of the Balance of Payment (as % of service exports) of Suriname in 2005 to that in 2007?
Make the answer very short. 0.83. What is the ratio of the Balance of Payment (as % of service exports) in Brunei Darussalam in 2005 to that in 2008?
Your answer should be compact. 1.11. What is the ratio of the Balance of Payment (as % of service exports) of Dominican Republic in 2005 to that in 2008?
Your answer should be compact. 0.94. What is the ratio of the Balance of Payment (as % of service exports) of Solomon Islands in 2005 to that in 2008?
Your response must be concise. 0.07. What is the ratio of the Balance of Payment (as % of service exports) of Suriname in 2005 to that in 2008?
Offer a terse response. 0.8. What is the ratio of the Balance of Payment (as % of service exports) in Brunei Darussalam in 2005 to that in 2009?
Ensure brevity in your answer.  1.12. What is the ratio of the Balance of Payment (as % of service exports) of Dominican Republic in 2005 to that in 2009?
Your answer should be compact. 0.88. What is the ratio of the Balance of Payment (as % of service exports) in Solomon Islands in 2005 to that in 2009?
Offer a terse response. 0.07. What is the ratio of the Balance of Payment (as % of service exports) of Suriname in 2005 to that in 2009?
Ensure brevity in your answer.  0.99. What is the ratio of the Balance of Payment (as % of service exports) of Brunei Darussalam in 2005 to that in 2012?
Give a very brief answer. 1.63. What is the ratio of the Balance of Payment (as % of service exports) of Dominican Republic in 2005 to that in 2012?
Provide a short and direct response. 0.75. What is the ratio of the Balance of Payment (as % of service exports) of Solomon Islands in 2005 to that in 2012?
Offer a very short reply. 0.08. What is the ratio of the Balance of Payment (as % of service exports) in Suriname in 2005 to that in 2012?
Provide a succinct answer. 0.53. What is the ratio of the Balance of Payment (as % of service exports) of Brunei Darussalam in 2006 to that in 2007?
Give a very brief answer. 1.05. What is the ratio of the Balance of Payment (as % of service exports) of Dominican Republic in 2006 to that in 2007?
Make the answer very short. 1. What is the ratio of the Balance of Payment (as % of service exports) in Solomon Islands in 2006 to that in 2007?
Offer a terse response. 1.04. What is the ratio of the Balance of Payment (as % of service exports) of Suriname in 2006 to that in 2007?
Your answer should be compact. 1.52. What is the ratio of the Balance of Payment (as % of service exports) of Brunei Darussalam in 2006 to that in 2008?
Offer a terse response. 1.08. What is the ratio of the Balance of Payment (as % of service exports) in Solomon Islands in 2006 to that in 2008?
Offer a very short reply. 0.78. What is the ratio of the Balance of Payment (as % of service exports) in Suriname in 2006 to that in 2008?
Make the answer very short. 1.47. What is the ratio of the Balance of Payment (as % of service exports) of Brunei Darussalam in 2006 to that in 2009?
Ensure brevity in your answer.  1.08. What is the ratio of the Balance of Payment (as % of service exports) of Dominican Republic in 2006 to that in 2009?
Keep it short and to the point. 0.92. What is the ratio of the Balance of Payment (as % of service exports) in Solomon Islands in 2006 to that in 2009?
Make the answer very short. 0.77. What is the ratio of the Balance of Payment (as % of service exports) in Suriname in 2006 to that in 2009?
Your answer should be very brief. 1.81. What is the ratio of the Balance of Payment (as % of service exports) in Brunei Darussalam in 2006 to that in 2012?
Ensure brevity in your answer.  1.58. What is the ratio of the Balance of Payment (as % of service exports) of Dominican Republic in 2006 to that in 2012?
Offer a very short reply. 0.77. What is the ratio of the Balance of Payment (as % of service exports) of Solomon Islands in 2006 to that in 2012?
Make the answer very short. 0.96. What is the ratio of the Balance of Payment (as % of service exports) of Suriname in 2006 to that in 2012?
Keep it short and to the point. 0.97. What is the ratio of the Balance of Payment (as % of service exports) in Brunei Darussalam in 2007 to that in 2008?
Give a very brief answer. 1.02. What is the ratio of the Balance of Payment (as % of service exports) in Dominican Republic in 2007 to that in 2008?
Offer a terse response. 0.98. What is the ratio of the Balance of Payment (as % of service exports) in Solomon Islands in 2007 to that in 2008?
Give a very brief answer. 0.75. What is the ratio of the Balance of Payment (as % of service exports) in Suriname in 2007 to that in 2008?
Your answer should be compact. 0.97. What is the ratio of the Balance of Payment (as % of service exports) of Brunei Darussalam in 2007 to that in 2009?
Provide a succinct answer. 1.03. What is the ratio of the Balance of Payment (as % of service exports) in Dominican Republic in 2007 to that in 2009?
Your response must be concise. 0.92. What is the ratio of the Balance of Payment (as % of service exports) in Solomon Islands in 2007 to that in 2009?
Make the answer very short. 0.74. What is the ratio of the Balance of Payment (as % of service exports) of Suriname in 2007 to that in 2009?
Offer a very short reply. 1.18. What is the ratio of the Balance of Payment (as % of service exports) of Brunei Darussalam in 2007 to that in 2012?
Make the answer very short. 1.51. What is the ratio of the Balance of Payment (as % of service exports) in Dominican Republic in 2007 to that in 2012?
Keep it short and to the point. 0.78. What is the ratio of the Balance of Payment (as % of service exports) of Solomon Islands in 2007 to that in 2012?
Offer a very short reply. 0.92. What is the ratio of the Balance of Payment (as % of service exports) of Suriname in 2007 to that in 2012?
Keep it short and to the point. 0.64. What is the ratio of the Balance of Payment (as % of service exports) of Brunei Darussalam in 2008 to that in 2009?
Provide a succinct answer. 1.01. What is the ratio of the Balance of Payment (as % of service exports) in Dominican Republic in 2008 to that in 2009?
Keep it short and to the point. 0.94. What is the ratio of the Balance of Payment (as % of service exports) of Solomon Islands in 2008 to that in 2009?
Provide a short and direct response. 0.98. What is the ratio of the Balance of Payment (as % of service exports) of Suriname in 2008 to that in 2009?
Offer a terse response. 1.23. What is the ratio of the Balance of Payment (as % of service exports) of Brunei Darussalam in 2008 to that in 2012?
Make the answer very short. 1.47. What is the ratio of the Balance of Payment (as % of service exports) of Dominican Republic in 2008 to that in 2012?
Your answer should be very brief. 0.79. What is the ratio of the Balance of Payment (as % of service exports) in Solomon Islands in 2008 to that in 2012?
Your answer should be compact. 1.22. What is the ratio of the Balance of Payment (as % of service exports) in Suriname in 2008 to that in 2012?
Offer a very short reply. 0.66. What is the ratio of the Balance of Payment (as % of service exports) in Brunei Darussalam in 2009 to that in 2012?
Give a very brief answer. 1.46. What is the ratio of the Balance of Payment (as % of service exports) in Dominican Republic in 2009 to that in 2012?
Your answer should be compact. 0.84. What is the ratio of the Balance of Payment (as % of service exports) in Solomon Islands in 2009 to that in 2012?
Provide a succinct answer. 1.24. What is the ratio of the Balance of Payment (as % of service exports) in Suriname in 2009 to that in 2012?
Keep it short and to the point. 0.54. What is the difference between the highest and the second highest Balance of Payment (as % of service exports) in Brunei Darussalam?
Ensure brevity in your answer.  0.98. What is the difference between the highest and the second highest Balance of Payment (as % of service exports) in Dominican Republic?
Your answer should be compact. 11.99. What is the difference between the highest and the second highest Balance of Payment (as % of service exports) in Solomon Islands?
Provide a succinct answer. 0.95. What is the difference between the highest and the second highest Balance of Payment (as % of service exports) of Suriname?
Offer a terse response. 1.14. What is the difference between the highest and the lowest Balance of Payment (as % of service exports) in Brunei Darussalam?
Provide a succinct answer. 12.05. What is the difference between the highest and the lowest Balance of Payment (as % of service exports) in Dominican Republic?
Your answer should be very brief. 19.41. What is the difference between the highest and the lowest Balance of Payment (as % of service exports) in Solomon Islands?
Give a very brief answer. 52.65. What is the difference between the highest and the lowest Balance of Payment (as % of service exports) in Suriname?
Make the answer very short. 19.35. 